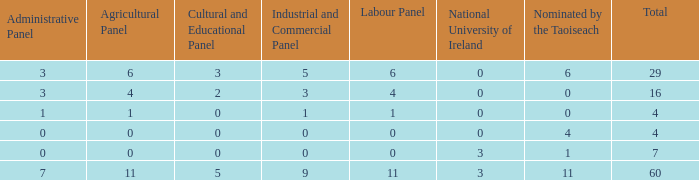What is the greatest number of nominations by taoiseach of the configuration with an administrative panel exceeding 0 and an industrial and commercial panel lesser than 1? None. 